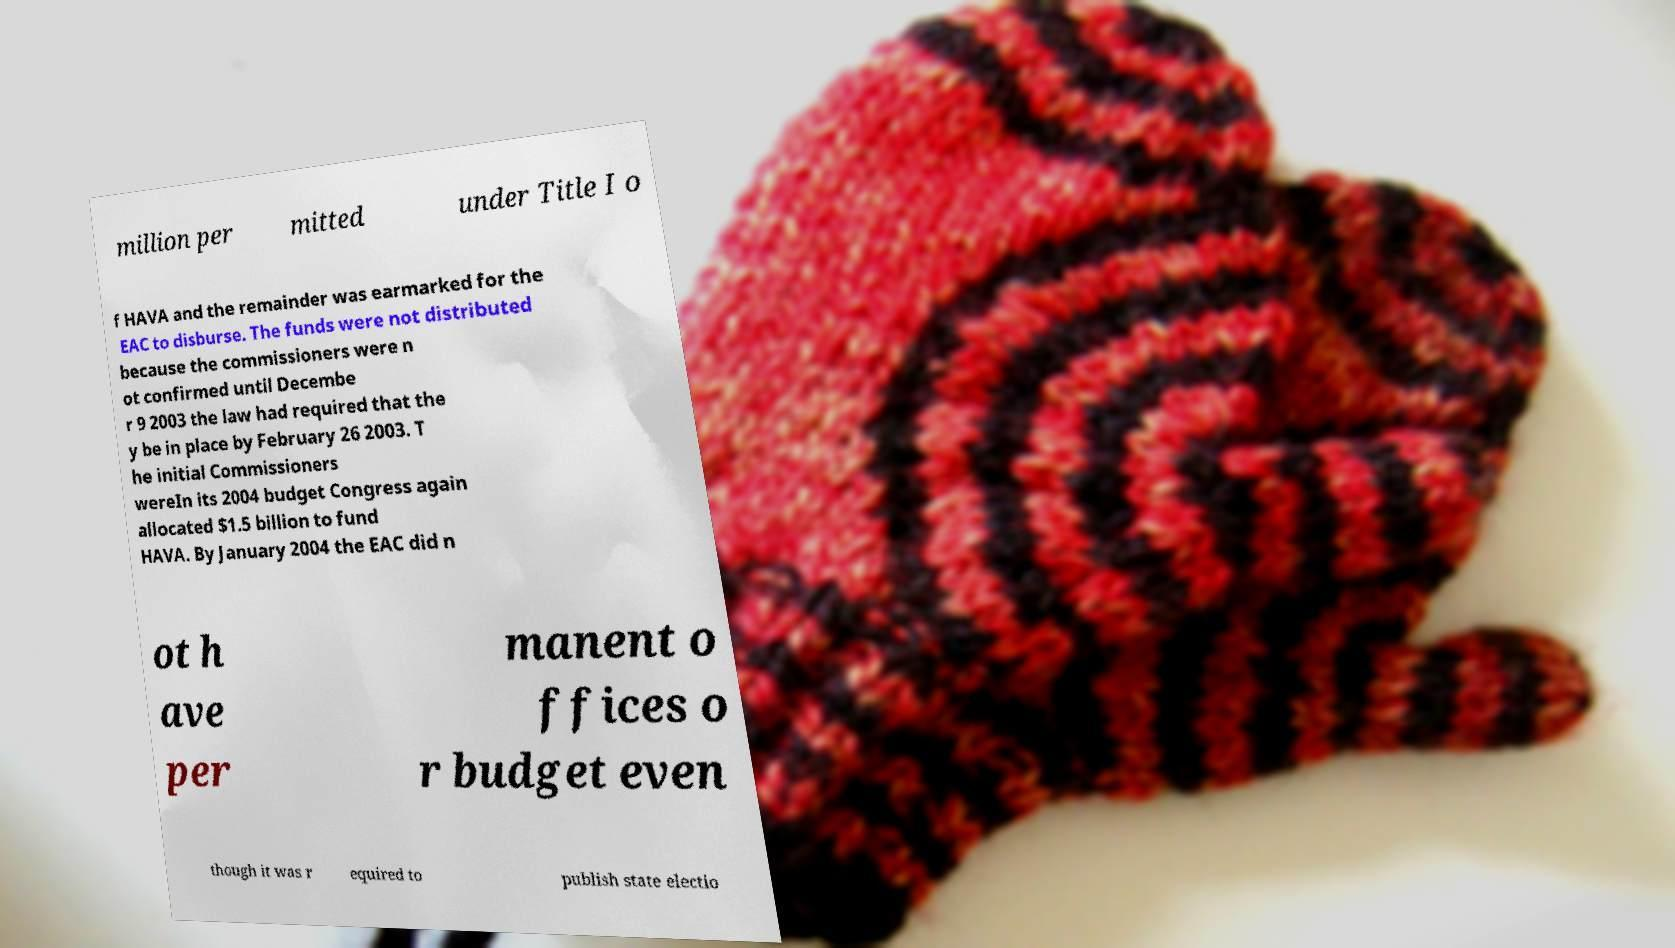Please identify and transcribe the text found in this image. million per mitted under Title I o f HAVA and the remainder was earmarked for the EAC to disburse. The funds were not distributed because the commissioners were n ot confirmed until Decembe r 9 2003 the law had required that the y be in place by February 26 2003. T he initial Commissioners wereIn its 2004 budget Congress again allocated $1.5 billion to fund HAVA. By January 2004 the EAC did n ot h ave per manent o ffices o r budget even though it was r equired to publish state electio 